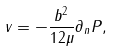<formula> <loc_0><loc_0><loc_500><loc_500>v = - \frac { b ^ { 2 } } { 1 2 \mu } \partial _ { n } P ,</formula> 